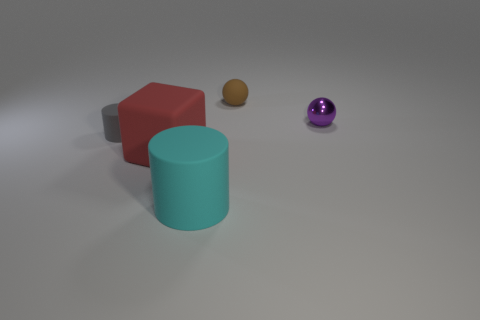There is a cylinder that is on the right side of the cylinder behind the cyan matte cylinder; what number of big objects are to the left of it?
Your answer should be very brief. 1. Is there any other thing of the same color as the cube?
Provide a succinct answer. No. What number of rubber things are on the right side of the tiny matte cylinder and in front of the small purple object?
Keep it short and to the point. 2. There is a ball left of the small purple object; does it have the same size as the cylinder that is in front of the big red cube?
Provide a short and direct response. No. How many objects are either small matte things behind the gray matte thing or brown cubes?
Provide a succinct answer. 1. What is the ball that is right of the small brown ball made of?
Your answer should be very brief. Metal. What is the material of the big cyan thing?
Offer a very short reply. Rubber. There is a purple object that is behind the large matte object left of the rubber cylinder that is to the right of the tiny gray rubber thing; what is it made of?
Your answer should be very brief. Metal. Is there anything else that is made of the same material as the purple ball?
Your answer should be compact. No. Does the gray matte object have the same size as the matte cylinder that is in front of the large block?
Make the answer very short. No. 